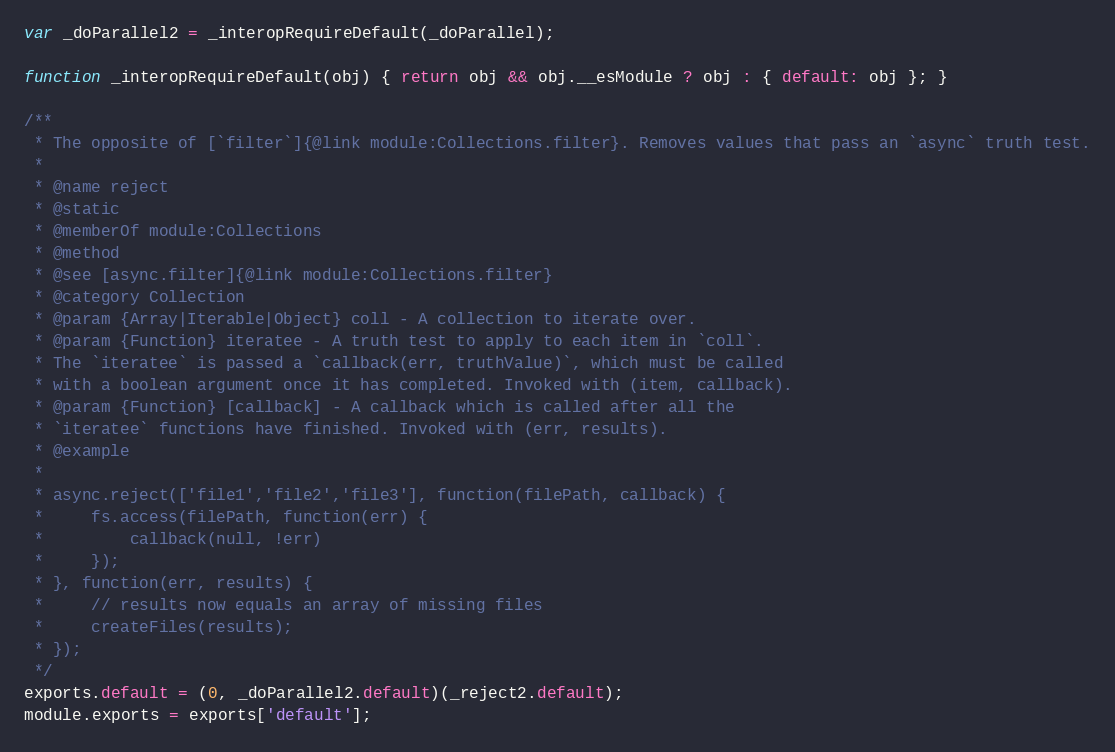Convert code to text. <code><loc_0><loc_0><loc_500><loc_500><_JavaScript_>
var _doParallel2 = _interopRequireDefault(_doParallel);

function _interopRequireDefault(obj) { return obj && obj.__esModule ? obj : { default: obj }; }

/**
 * The opposite of [`filter`]{@link module:Collections.filter}. Removes values that pass an `async` truth test.
 *
 * @name reject
 * @static
 * @memberOf module:Collections
 * @method
 * @see [async.filter]{@link module:Collections.filter}
 * @category Collection
 * @param {Array|Iterable|Object} coll - A collection to iterate over.
 * @param {Function} iteratee - A truth test to apply to each item in `coll`.
 * The `iteratee` is passed a `callback(err, truthValue)`, which must be called
 * with a boolean argument once it has completed. Invoked with (item, callback).
 * @param {Function} [callback] - A callback which is called after all the
 * `iteratee` functions have finished. Invoked with (err, results).
 * @example
 *
 * async.reject(['file1','file2','file3'], function(filePath, callback) {
 *     fs.access(filePath, function(err) {
 *         callback(null, !err)
 *     });
 * }, function(err, results) {
 *     // results now equals an array of missing files
 *     createFiles(results);
 * });
 */
exports.default = (0, _doParallel2.default)(_reject2.default);
module.exports = exports['default'];</code> 